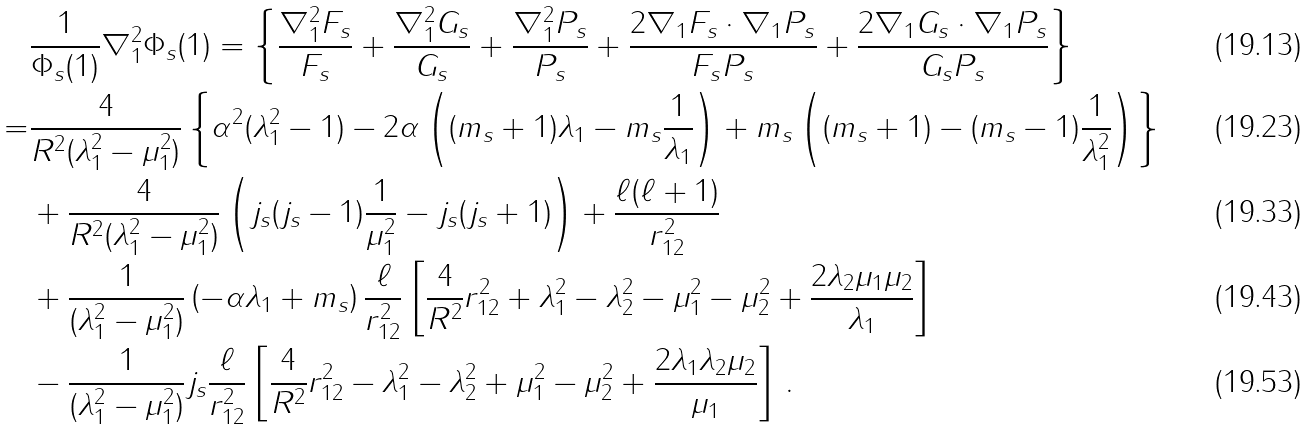Convert formula to latex. <formula><loc_0><loc_0><loc_500><loc_500>& \frac { 1 } { \Phi _ { s } ( 1 ) } \nabla ^ { 2 } _ { 1 } \Phi _ { s } ( 1 ) = \left \{ \frac { \nabla _ { 1 } ^ { 2 } F _ { s } } { F _ { s } } + \frac { \nabla _ { 1 } ^ { 2 } G _ { s } } { G _ { s } } + \frac { \nabla _ { 1 } ^ { 2 } P _ { s } } { P _ { s } } + \frac { 2 \nabla _ { 1 } F _ { s } \cdot \nabla _ { 1 } P _ { s } } { F _ { s } P _ { s } } + \frac { 2 \nabla _ { 1 } G _ { s } \cdot \nabla _ { 1 } P _ { s } } { G _ { s } P _ { s } } \right \} \\ = & \frac { 4 } { R ^ { 2 } ( \lambda _ { 1 } ^ { 2 } - \mu _ { 1 } ^ { 2 } ) } \left \{ \alpha ^ { 2 } ( \lambda _ { 1 } ^ { 2 } - 1 ) - 2 \alpha \left ( ( m _ { s } + 1 ) \lambda _ { 1 } - m _ { s } \frac { 1 } { \lambda _ { 1 } } \right ) + m _ { s } \left ( ( m _ { s } + 1 ) - ( m _ { s } - 1 ) \frac { 1 } { \lambda _ { 1 } ^ { 2 } } \right ) \right \} \\ & + \frac { 4 } { R ^ { 2 } ( \lambda _ { 1 } ^ { 2 } - \mu _ { 1 } ^ { 2 } ) } \left ( j _ { s } ( j _ { s } - 1 ) \frac { 1 } { \mu _ { 1 } ^ { 2 } } - j _ { s } ( j _ { s } + 1 ) \right ) + \frac { \ell ( \ell + 1 ) } { r _ { 1 2 } ^ { 2 } } \\ & + \frac { 1 } { ( \lambda _ { 1 } ^ { 2 } - \mu _ { 1 } ^ { 2 } ) } \left ( - \alpha \lambda _ { 1 } + m _ { s } \right ) \frac { \ell } { r _ { 1 2 } ^ { 2 } } \left [ \frac { 4 } { R ^ { 2 } } r _ { 1 2 } ^ { 2 } + \lambda _ { 1 } ^ { 2 } - \lambda _ { 2 } ^ { 2 } - \mu _ { 1 } ^ { 2 } - \mu _ { 2 } ^ { 2 } + \frac { 2 \lambda _ { 2 } \mu _ { 1 } \mu _ { 2 } } { \lambda _ { 1 } } \right ] \\ & - \frac { 1 } { ( \lambda _ { 1 } ^ { 2 } - \mu _ { 1 } ^ { 2 } ) } j _ { s } \frac { \ell } { r _ { 1 2 } ^ { 2 } } \left [ \frac { 4 } { R ^ { 2 } } r _ { 1 2 } ^ { 2 } - \lambda _ { 1 } ^ { 2 } - \lambda _ { 2 } ^ { 2 } + \mu _ { 1 } ^ { 2 } - \mu _ { 2 } ^ { 2 } + \frac { 2 \lambda _ { 1 } \lambda _ { 2 } \mu _ { 2 } } { \mu _ { 1 } } \right ] \, .</formula> 